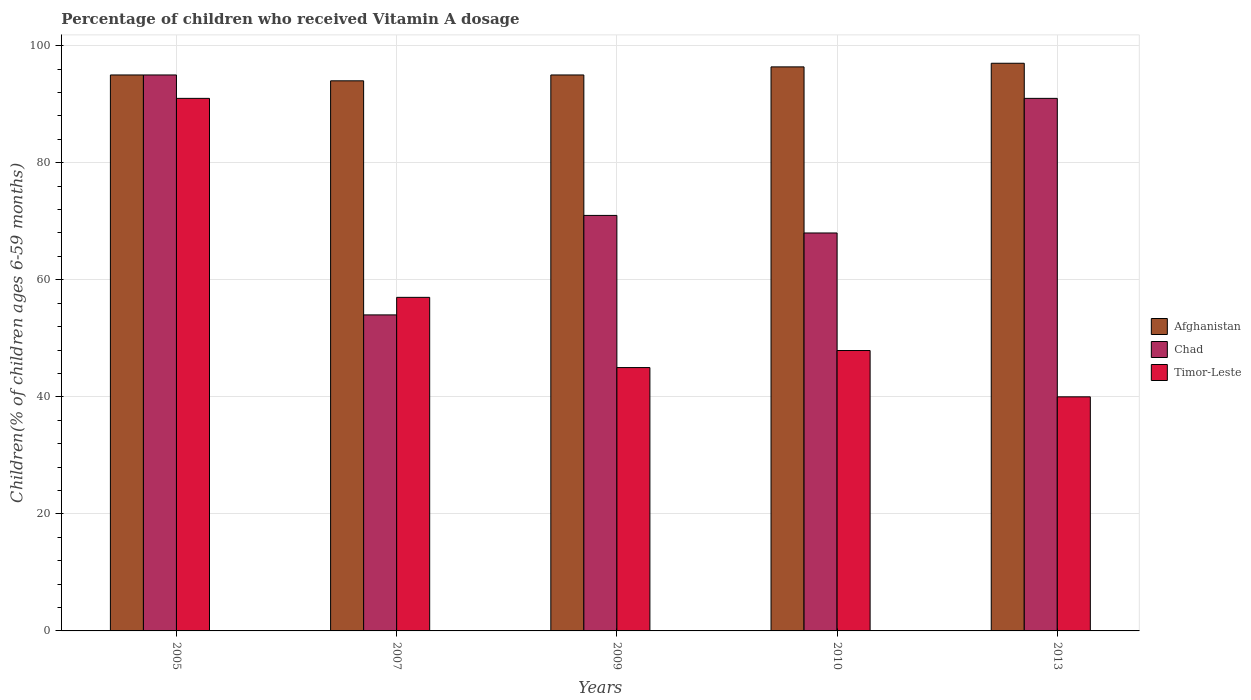How many different coloured bars are there?
Ensure brevity in your answer.  3. How many groups of bars are there?
Give a very brief answer. 5. How many bars are there on the 2nd tick from the left?
Your answer should be compact. 3. What is the label of the 1st group of bars from the left?
Provide a short and direct response. 2005. In how many cases, is the number of bars for a given year not equal to the number of legend labels?
Ensure brevity in your answer.  0. What is the percentage of children who received Vitamin A dosage in Chad in 2005?
Make the answer very short. 95. Across all years, what is the maximum percentage of children who received Vitamin A dosage in Chad?
Ensure brevity in your answer.  95. Across all years, what is the minimum percentage of children who received Vitamin A dosage in Afghanistan?
Offer a very short reply. 94. In which year was the percentage of children who received Vitamin A dosage in Timor-Leste maximum?
Offer a terse response. 2005. In which year was the percentage of children who received Vitamin A dosage in Afghanistan minimum?
Ensure brevity in your answer.  2007. What is the total percentage of children who received Vitamin A dosage in Chad in the graph?
Offer a very short reply. 379. What is the average percentage of children who received Vitamin A dosage in Chad per year?
Offer a very short reply. 75.8. In the year 2007, what is the difference between the percentage of children who received Vitamin A dosage in Timor-Leste and percentage of children who received Vitamin A dosage in Afghanistan?
Offer a very short reply. -37. What is the ratio of the percentage of children who received Vitamin A dosage in Afghanistan in 2005 to that in 2010?
Provide a short and direct response. 0.99. What is the difference between the highest and the second highest percentage of children who received Vitamin A dosage in Afghanistan?
Your answer should be compact. 0.62. Is the sum of the percentage of children who received Vitamin A dosage in Afghanistan in 2007 and 2009 greater than the maximum percentage of children who received Vitamin A dosage in Chad across all years?
Ensure brevity in your answer.  Yes. What does the 1st bar from the left in 2009 represents?
Your answer should be compact. Afghanistan. What does the 1st bar from the right in 2005 represents?
Make the answer very short. Timor-Leste. Is it the case that in every year, the sum of the percentage of children who received Vitamin A dosage in Chad and percentage of children who received Vitamin A dosage in Afghanistan is greater than the percentage of children who received Vitamin A dosage in Timor-Leste?
Keep it short and to the point. Yes. How many years are there in the graph?
Make the answer very short. 5. What is the difference between two consecutive major ticks on the Y-axis?
Give a very brief answer. 20. Are the values on the major ticks of Y-axis written in scientific E-notation?
Keep it short and to the point. No. Does the graph contain any zero values?
Keep it short and to the point. No. Does the graph contain grids?
Your answer should be compact. Yes. How are the legend labels stacked?
Make the answer very short. Vertical. What is the title of the graph?
Your answer should be very brief. Percentage of children who received Vitamin A dosage. Does "Czech Republic" appear as one of the legend labels in the graph?
Your answer should be compact. No. What is the label or title of the Y-axis?
Your answer should be compact. Children(% of children ages 6-59 months). What is the Children(% of children ages 6-59 months) of Timor-Leste in 2005?
Offer a terse response. 91. What is the Children(% of children ages 6-59 months) in Afghanistan in 2007?
Your response must be concise. 94. What is the Children(% of children ages 6-59 months) in Chad in 2007?
Your answer should be compact. 54. What is the Children(% of children ages 6-59 months) of Afghanistan in 2009?
Keep it short and to the point. 95. What is the Children(% of children ages 6-59 months) of Timor-Leste in 2009?
Ensure brevity in your answer.  45. What is the Children(% of children ages 6-59 months) of Afghanistan in 2010?
Provide a short and direct response. 96.38. What is the Children(% of children ages 6-59 months) of Chad in 2010?
Your response must be concise. 68. What is the Children(% of children ages 6-59 months) of Timor-Leste in 2010?
Your response must be concise. 47.91. What is the Children(% of children ages 6-59 months) in Afghanistan in 2013?
Keep it short and to the point. 97. What is the Children(% of children ages 6-59 months) of Chad in 2013?
Offer a very short reply. 91. What is the Children(% of children ages 6-59 months) of Timor-Leste in 2013?
Offer a very short reply. 40. Across all years, what is the maximum Children(% of children ages 6-59 months) of Afghanistan?
Provide a succinct answer. 97. Across all years, what is the maximum Children(% of children ages 6-59 months) in Chad?
Provide a succinct answer. 95. Across all years, what is the maximum Children(% of children ages 6-59 months) in Timor-Leste?
Offer a very short reply. 91. Across all years, what is the minimum Children(% of children ages 6-59 months) in Afghanistan?
Give a very brief answer. 94. Across all years, what is the minimum Children(% of children ages 6-59 months) in Timor-Leste?
Offer a terse response. 40. What is the total Children(% of children ages 6-59 months) in Afghanistan in the graph?
Ensure brevity in your answer.  477.38. What is the total Children(% of children ages 6-59 months) of Chad in the graph?
Make the answer very short. 379. What is the total Children(% of children ages 6-59 months) in Timor-Leste in the graph?
Ensure brevity in your answer.  280.91. What is the difference between the Children(% of children ages 6-59 months) in Timor-Leste in 2005 and that in 2007?
Offer a very short reply. 34. What is the difference between the Children(% of children ages 6-59 months) in Afghanistan in 2005 and that in 2009?
Offer a terse response. 0. What is the difference between the Children(% of children ages 6-59 months) of Afghanistan in 2005 and that in 2010?
Provide a succinct answer. -1.38. What is the difference between the Children(% of children ages 6-59 months) of Chad in 2005 and that in 2010?
Provide a short and direct response. 27. What is the difference between the Children(% of children ages 6-59 months) in Timor-Leste in 2005 and that in 2010?
Ensure brevity in your answer.  43.09. What is the difference between the Children(% of children ages 6-59 months) of Afghanistan in 2005 and that in 2013?
Give a very brief answer. -2. What is the difference between the Children(% of children ages 6-59 months) of Chad in 2007 and that in 2009?
Provide a short and direct response. -17. What is the difference between the Children(% of children ages 6-59 months) in Afghanistan in 2007 and that in 2010?
Offer a terse response. -2.38. What is the difference between the Children(% of children ages 6-59 months) in Timor-Leste in 2007 and that in 2010?
Your response must be concise. 9.09. What is the difference between the Children(% of children ages 6-59 months) in Chad in 2007 and that in 2013?
Your answer should be very brief. -37. What is the difference between the Children(% of children ages 6-59 months) of Timor-Leste in 2007 and that in 2013?
Your answer should be compact. 17. What is the difference between the Children(% of children ages 6-59 months) of Afghanistan in 2009 and that in 2010?
Keep it short and to the point. -1.38. What is the difference between the Children(% of children ages 6-59 months) of Timor-Leste in 2009 and that in 2010?
Offer a terse response. -2.91. What is the difference between the Children(% of children ages 6-59 months) of Afghanistan in 2009 and that in 2013?
Ensure brevity in your answer.  -2. What is the difference between the Children(% of children ages 6-59 months) in Timor-Leste in 2009 and that in 2013?
Make the answer very short. 5. What is the difference between the Children(% of children ages 6-59 months) in Afghanistan in 2010 and that in 2013?
Keep it short and to the point. -0.62. What is the difference between the Children(% of children ages 6-59 months) of Timor-Leste in 2010 and that in 2013?
Your response must be concise. 7.91. What is the difference between the Children(% of children ages 6-59 months) in Afghanistan in 2005 and the Children(% of children ages 6-59 months) in Timor-Leste in 2007?
Your answer should be very brief. 38. What is the difference between the Children(% of children ages 6-59 months) of Afghanistan in 2005 and the Children(% of children ages 6-59 months) of Timor-Leste in 2009?
Keep it short and to the point. 50. What is the difference between the Children(% of children ages 6-59 months) of Chad in 2005 and the Children(% of children ages 6-59 months) of Timor-Leste in 2009?
Your answer should be very brief. 50. What is the difference between the Children(% of children ages 6-59 months) in Afghanistan in 2005 and the Children(% of children ages 6-59 months) in Timor-Leste in 2010?
Make the answer very short. 47.09. What is the difference between the Children(% of children ages 6-59 months) in Chad in 2005 and the Children(% of children ages 6-59 months) in Timor-Leste in 2010?
Make the answer very short. 47.09. What is the difference between the Children(% of children ages 6-59 months) in Afghanistan in 2005 and the Children(% of children ages 6-59 months) in Timor-Leste in 2013?
Your answer should be very brief. 55. What is the difference between the Children(% of children ages 6-59 months) of Afghanistan in 2007 and the Children(% of children ages 6-59 months) of Timor-Leste in 2009?
Provide a short and direct response. 49. What is the difference between the Children(% of children ages 6-59 months) of Chad in 2007 and the Children(% of children ages 6-59 months) of Timor-Leste in 2009?
Your answer should be compact. 9. What is the difference between the Children(% of children ages 6-59 months) in Afghanistan in 2007 and the Children(% of children ages 6-59 months) in Chad in 2010?
Provide a succinct answer. 26. What is the difference between the Children(% of children ages 6-59 months) of Afghanistan in 2007 and the Children(% of children ages 6-59 months) of Timor-Leste in 2010?
Offer a terse response. 46.09. What is the difference between the Children(% of children ages 6-59 months) of Chad in 2007 and the Children(% of children ages 6-59 months) of Timor-Leste in 2010?
Give a very brief answer. 6.09. What is the difference between the Children(% of children ages 6-59 months) in Afghanistan in 2007 and the Children(% of children ages 6-59 months) in Chad in 2013?
Offer a very short reply. 3. What is the difference between the Children(% of children ages 6-59 months) of Afghanistan in 2007 and the Children(% of children ages 6-59 months) of Timor-Leste in 2013?
Make the answer very short. 54. What is the difference between the Children(% of children ages 6-59 months) in Afghanistan in 2009 and the Children(% of children ages 6-59 months) in Timor-Leste in 2010?
Keep it short and to the point. 47.09. What is the difference between the Children(% of children ages 6-59 months) of Chad in 2009 and the Children(% of children ages 6-59 months) of Timor-Leste in 2010?
Provide a succinct answer. 23.09. What is the difference between the Children(% of children ages 6-59 months) of Afghanistan in 2009 and the Children(% of children ages 6-59 months) of Chad in 2013?
Make the answer very short. 4. What is the difference between the Children(% of children ages 6-59 months) in Chad in 2009 and the Children(% of children ages 6-59 months) in Timor-Leste in 2013?
Provide a short and direct response. 31. What is the difference between the Children(% of children ages 6-59 months) of Afghanistan in 2010 and the Children(% of children ages 6-59 months) of Chad in 2013?
Provide a succinct answer. 5.38. What is the difference between the Children(% of children ages 6-59 months) of Afghanistan in 2010 and the Children(% of children ages 6-59 months) of Timor-Leste in 2013?
Provide a succinct answer. 56.38. What is the difference between the Children(% of children ages 6-59 months) of Chad in 2010 and the Children(% of children ages 6-59 months) of Timor-Leste in 2013?
Give a very brief answer. 28. What is the average Children(% of children ages 6-59 months) in Afghanistan per year?
Offer a very short reply. 95.48. What is the average Children(% of children ages 6-59 months) of Chad per year?
Keep it short and to the point. 75.8. What is the average Children(% of children ages 6-59 months) in Timor-Leste per year?
Ensure brevity in your answer.  56.18. In the year 2005, what is the difference between the Children(% of children ages 6-59 months) in Afghanistan and Children(% of children ages 6-59 months) in Chad?
Keep it short and to the point. 0. In the year 2005, what is the difference between the Children(% of children ages 6-59 months) of Afghanistan and Children(% of children ages 6-59 months) of Timor-Leste?
Make the answer very short. 4. In the year 2005, what is the difference between the Children(% of children ages 6-59 months) of Chad and Children(% of children ages 6-59 months) of Timor-Leste?
Offer a terse response. 4. In the year 2009, what is the difference between the Children(% of children ages 6-59 months) of Afghanistan and Children(% of children ages 6-59 months) of Chad?
Give a very brief answer. 24. In the year 2009, what is the difference between the Children(% of children ages 6-59 months) in Afghanistan and Children(% of children ages 6-59 months) in Timor-Leste?
Your response must be concise. 50. In the year 2009, what is the difference between the Children(% of children ages 6-59 months) of Chad and Children(% of children ages 6-59 months) of Timor-Leste?
Your response must be concise. 26. In the year 2010, what is the difference between the Children(% of children ages 6-59 months) in Afghanistan and Children(% of children ages 6-59 months) in Chad?
Give a very brief answer. 28.38. In the year 2010, what is the difference between the Children(% of children ages 6-59 months) in Afghanistan and Children(% of children ages 6-59 months) in Timor-Leste?
Offer a terse response. 48.47. In the year 2010, what is the difference between the Children(% of children ages 6-59 months) of Chad and Children(% of children ages 6-59 months) of Timor-Leste?
Your response must be concise. 20.09. In the year 2013, what is the difference between the Children(% of children ages 6-59 months) in Chad and Children(% of children ages 6-59 months) in Timor-Leste?
Keep it short and to the point. 51. What is the ratio of the Children(% of children ages 6-59 months) of Afghanistan in 2005 to that in 2007?
Give a very brief answer. 1.01. What is the ratio of the Children(% of children ages 6-59 months) in Chad in 2005 to that in 2007?
Keep it short and to the point. 1.76. What is the ratio of the Children(% of children ages 6-59 months) of Timor-Leste in 2005 to that in 2007?
Ensure brevity in your answer.  1.6. What is the ratio of the Children(% of children ages 6-59 months) of Chad in 2005 to that in 2009?
Provide a succinct answer. 1.34. What is the ratio of the Children(% of children ages 6-59 months) of Timor-Leste in 2005 to that in 2009?
Your answer should be very brief. 2.02. What is the ratio of the Children(% of children ages 6-59 months) of Afghanistan in 2005 to that in 2010?
Provide a short and direct response. 0.99. What is the ratio of the Children(% of children ages 6-59 months) in Chad in 2005 to that in 2010?
Your answer should be very brief. 1.4. What is the ratio of the Children(% of children ages 6-59 months) of Timor-Leste in 2005 to that in 2010?
Give a very brief answer. 1.9. What is the ratio of the Children(% of children ages 6-59 months) in Afghanistan in 2005 to that in 2013?
Offer a very short reply. 0.98. What is the ratio of the Children(% of children ages 6-59 months) in Chad in 2005 to that in 2013?
Ensure brevity in your answer.  1.04. What is the ratio of the Children(% of children ages 6-59 months) in Timor-Leste in 2005 to that in 2013?
Provide a succinct answer. 2.27. What is the ratio of the Children(% of children ages 6-59 months) in Chad in 2007 to that in 2009?
Your response must be concise. 0.76. What is the ratio of the Children(% of children ages 6-59 months) of Timor-Leste in 2007 to that in 2009?
Your answer should be compact. 1.27. What is the ratio of the Children(% of children ages 6-59 months) of Afghanistan in 2007 to that in 2010?
Keep it short and to the point. 0.98. What is the ratio of the Children(% of children ages 6-59 months) in Chad in 2007 to that in 2010?
Make the answer very short. 0.79. What is the ratio of the Children(% of children ages 6-59 months) in Timor-Leste in 2007 to that in 2010?
Keep it short and to the point. 1.19. What is the ratio of the Children(% of children ages 6-59 months) in Afghanistan in 2007 to that in 2013?
Provide a short and direct response. 0.97. What is the ratio of the Children(% of children ages 6-59 months) in Chad in 2007 to that in 2013?
Provide a succinct answer. 0.59. What is the ratio of the Children(% of children ages 6-59 months) in Timor-Leste in 2007 to that in 2013?
Provide a succinct answer. 1.43. What is the ratio of the Children(% of children ages 6-59 months) in Afghanistan in 2009 to that in 2010?
Make the answer very short. 0.99. What is the ratio of the Children(% of children ages 6-59 months) in Chad in 2009 to that in 2010?
Your response must be concise. 1.04. What is the ratio of the Children(% of children ages 6-59 months) in Timor-Leste in 2009 to that in 2010?
Ensure brevity in your answer.  0.94. What is the ratio of the Children(% of children ages 6-59 months) of Afghanistan in 2009 to that in 2013?
Offer a terse response. 0.98. What is the ratio of the Children(% of children ages 6-59 months) in Chad in 2009 to that in 2013?
Offer a very short reply. 0.78. What is the ratio of the Children(% of children ages 6-59 months) in Afghanistan in 2010 to that in 2013?
Ensure brevity in your answer.  0.99. What is the ratio of the Children(% of children ages 6-59 months) in Chad in 2010 to that in 2013?
Provide a succinct answer. 0.75. What is the ratio of the Children(% of children ages 6-59 months) of Timor-Leste in 2010 to that in 2013?
Keep it short and to the point. 1.2. What is the difference between the highest and the second highest Children(% of children ages 6-59 months) of Afghanistan?
Provide a succinct answer. 0.62. What is the difference between the highest and the second highest Children(% of children ages 6-59 months) of Chad?
Your response must be concise. 4. What is the difference between the highest and the lowest Children(% of children ages 6-59 months) in Afghanistan?
Provide a succinct answer. 3. What is the difference between the highest and the lowest Children(% of children ages 6-59 months) of Chad?
Ensure brevity in your answer.  41. 